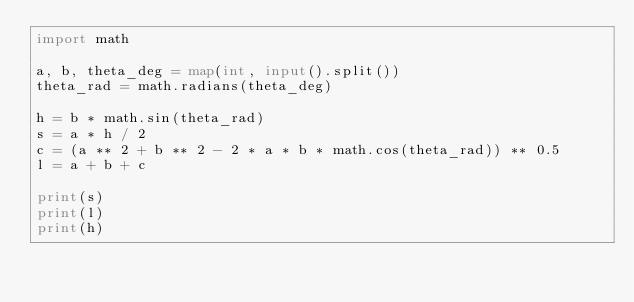Convert code to text. <code><loc_0><loc_0><loc_500><loc_500><_Python_>import math

a, b, theta_deg = map(int, input().split())
theta_rad = math.radians(theta_deg)

h = b * math.sin(theta_rad)
s = a * h / 2
c = (a ** 2 + b ** 2 - 2 * a * b * math.cos(theta_rad)) ** 0.5
l = a + b + c

print(s)
print(l)
print(h)
</code> 